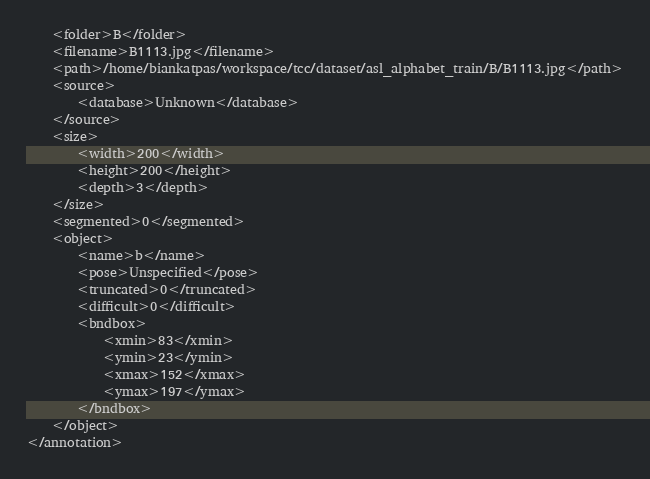<code> <loc_0><loc_0><loc_500><loc_500><_XML_>	<folder>B</folder>
	<filename>B1113.jpg</filename>
	<path>/home/biankatpas/workspace/tcc/dataset/asl_alphabet_train/B/B1113.jpg</path>
	<source>
		<database>Unknown</database>
	</source>
	<size>
		<width>200</width>
		<height>200</height>
		<depth>3</depth>
	</size>
	<segmented>0</segmented>
	<object>
		<name>b</name>
		<pose>Unspecified</pose>
		<truncated>0</truncated>
		<difficult>0</difficult>
		<bndbox>
			<xmin>83</xmin>
			<ymin>23</ymin>
			<xmax>152</xmax>
			<ymax>197</ymax>
		</bndbox>
	</object>
</annotation>
</code> 